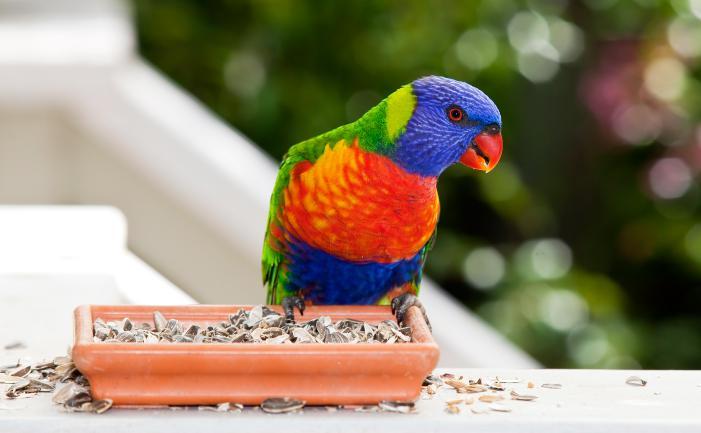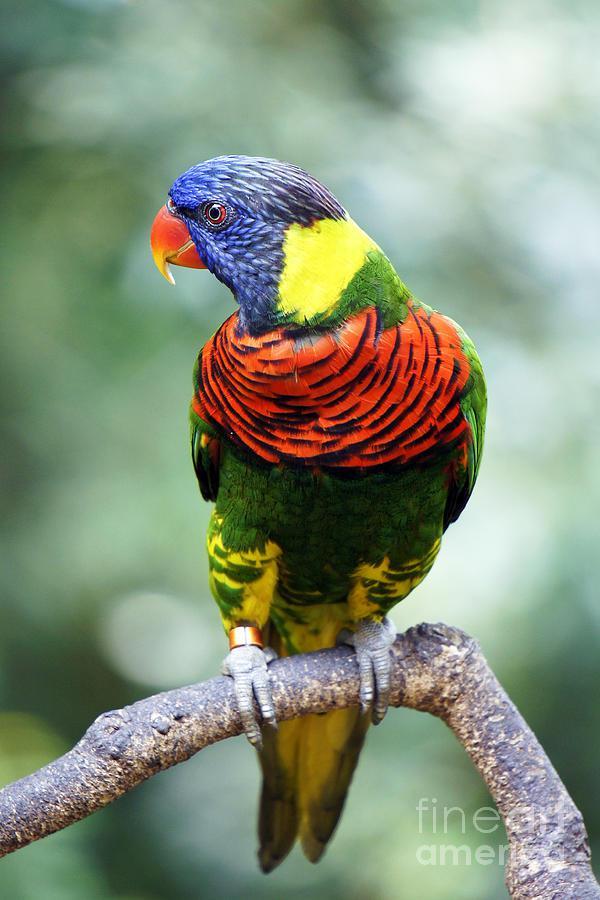The first image is the image on the left, the second image is the image on the right. Considering the images on both sides, is "An image contains only one left-facing parrot perched on some object." valid? Answer yes or no. Yes. The first image is the image on the left, the second image is the image on the right. For the images displayed, is the sentence "There are no more than 3 birds." factually correct? Answer yes or no. Yes. 